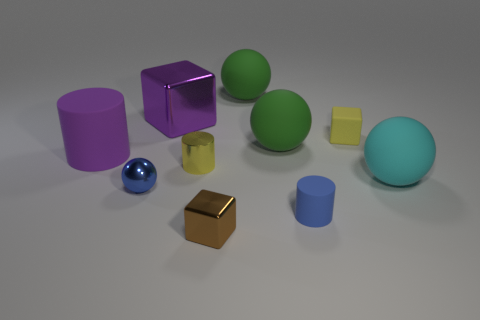What is the material of the small thing that is the same color as the tiny shiny ball?
Offer a terse response. Rubber. There is a yellow cylinder that is the same size as the metal sphere; what is its material?
Your response must be concise. Metal. What is the size of the blue thing left of the green object to the right of the big matte object that is behind the big purple shiny thing?
Keep it short and to the point. Small. Do the cylinder on the right side of the brown shiny block and the big rubber ball to the right of the yellow rubber cube have the same color?
Offer a terse response. No. What number of blue objects are either large metal things or small matte cylinders?
Offer a terse response. 1. How many purple cylinders have the same size as the yellow cube?
Provide a succinct answer. 0. Is the small yellow thing that is right of the brown shiny cube made of the same material as the large cyan thing?
Provide a short and direct response. Yes. Are there any objects that are to the left of the object that is on the left side of the tiny blue metallic object?
Ensure brevity in your answer.  No. There is a purple object that is the same shape as the yellow shiny thing; what is its material?
Make the answer very short. Rubber. Are there more tiny blue balls behind the tiny yellow rubber cube than green matte objects that are in front of the tiny brown thing?
Provide a short and direct response. No. 